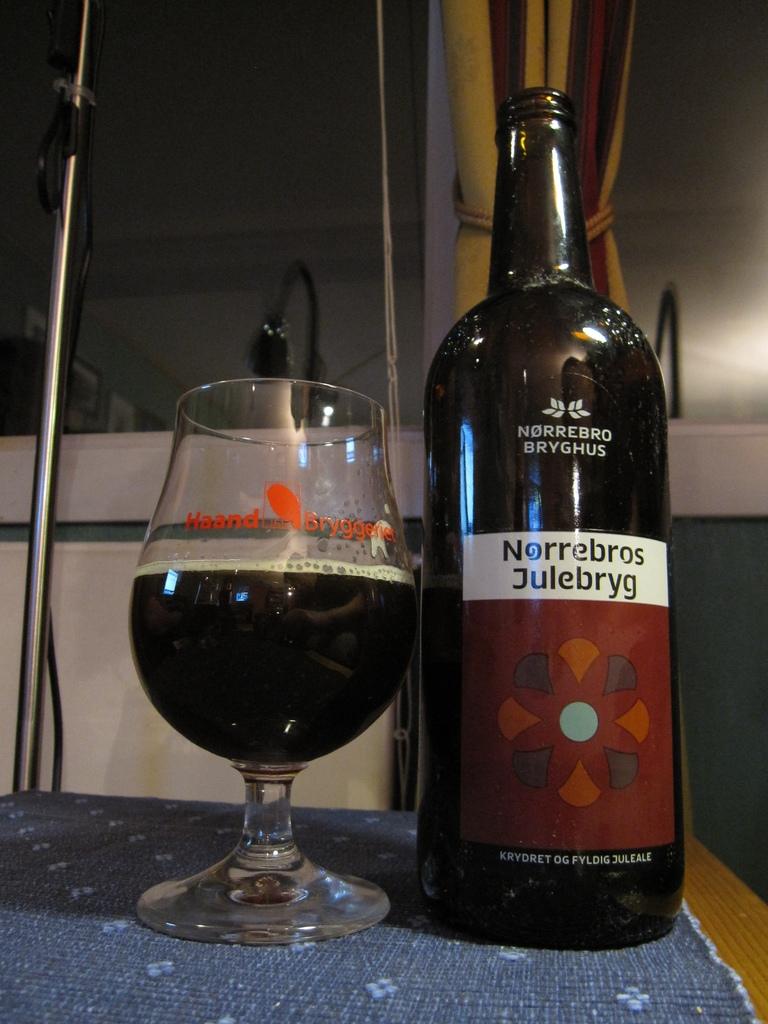What brand of drink is that?
Give a very brief answer. Norrebro bryghus. Who makes this drink?
Provide a short and direct response. Norrebros julebryg. 